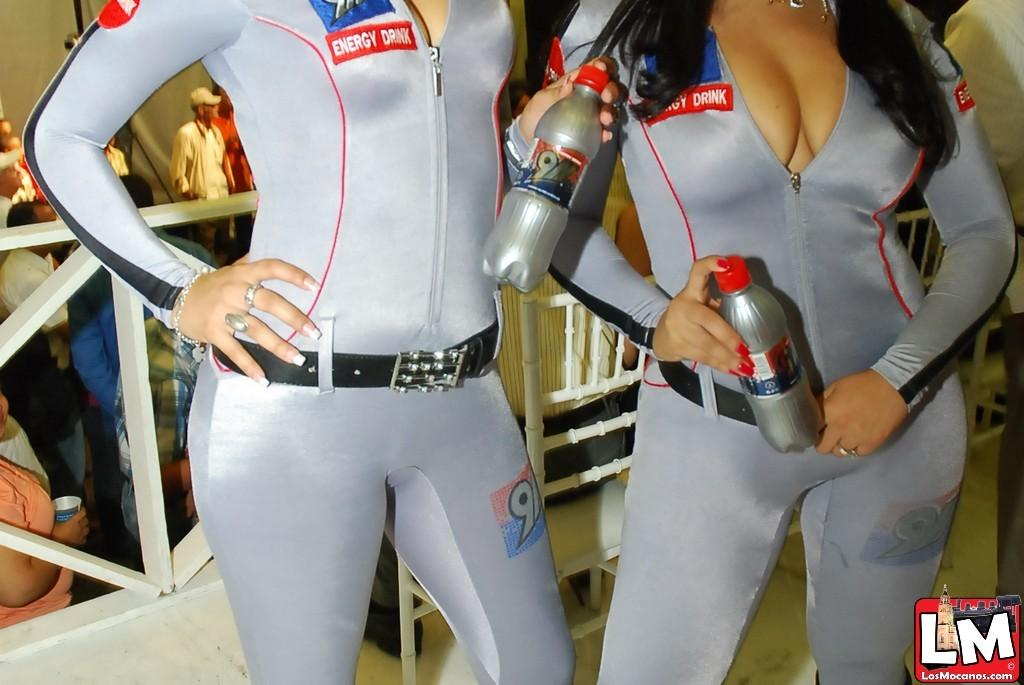<image>
Relay a brief, clear account of the picture shown. the words LM are on the side of a photo 